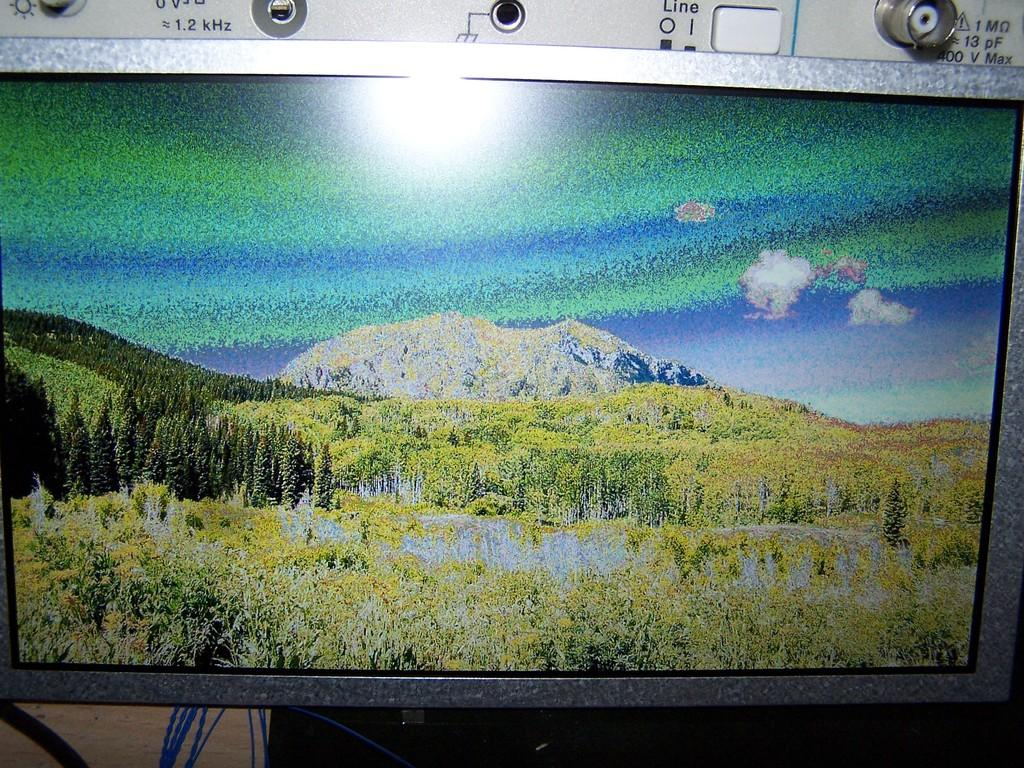<image>
Create a compact narrative representing the image presented. Computer monitor in front of a switch that says "LINE". 